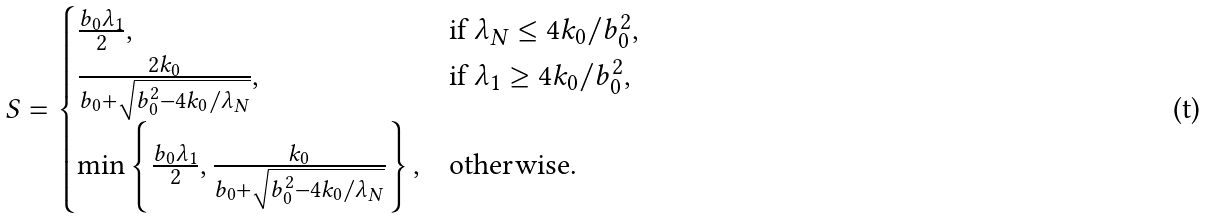Convert formula to latex. <formula><loc_0><loc_0><loc_500><loc_500>S = \begin{cases} \frac { b _ { 0 } \lambda _ { 1 } } { 2 } , & \text {if } \lambda _ { N } \leq 4 k _ { 0 } / b _ { 0 } ^ { 2 } , \\ \frac { 2 k _ { 0 } } { b _ { 0 } + \sqrt { b _ { 0 } ^ { 2 } - 4 k _ { 0 } / \lambda _ { N } } } , & \text {if } \lambda _ { 1 } \geq 4 k _ { 0 } / b _ { 0 } ^ { 2 } , \\ \min \left \{ \frac { b _ { 0 } \lambda _ { 1 } } { 2 } , \frac { k _ { 0 } } { b _ { 0 } + \sqrt { b _ { 0 } ^ { 2 } - 4 k _ { 0 } / \lambda _ { N } } } \right \} , & \text {otherwise.} \end{cases}</formula> 